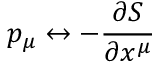Convert formula to latex. <formula><loc_0><loc_0><loc_500><loc_500>p _ { \mu } \leftrightarrow - { \frac { \partial S } { \partial x ^ { \mu } } }</formula> 